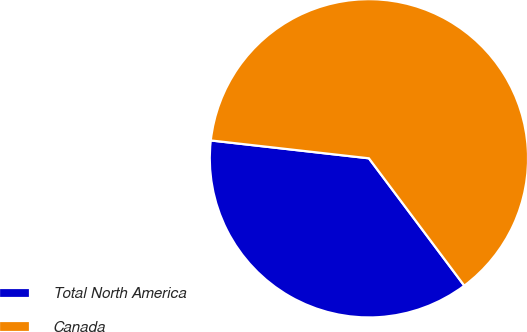<chart> <loc_0><loc_0><loc_500><loc_500><pie_chart><fcel>Total North America<fcel>Canada<nl><fcel>37.02%<fcel>62.98%<nl></chart> 